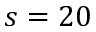<formula> <loc_0><loc_0><loc_500><loc_500>s = 2 0</formula> 